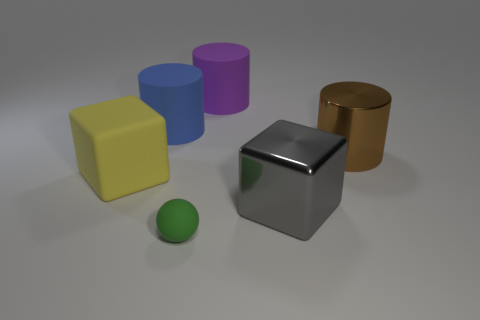Is the number of big brown objects on the left side of the blue object greater than the number of yellow cubes that are to the left of the large yellow rubber object? no 